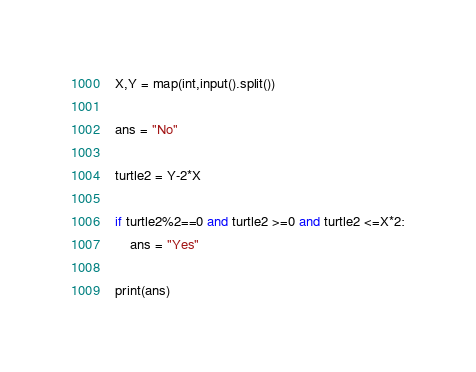Convert code to text. <code><loc_0><loc_0><loc_500><loc_500><_Python_>X,Y = map(int,input().split())

ans = "No"

turtle2 = Y-2*X

if turtle2%2==0 and turtle2 >=0 and turtle2 <=X*2:
    ans = "Yes"

print(ans)</code> 